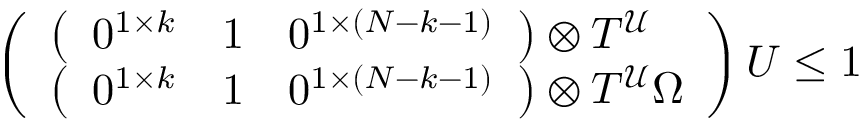Convert formula to latex. <formula><loc_0><loc_0><loc_500><loc_500>\begin{array} { r l } & { \left ( \begin{array} { l } { \left ( \begin{array} { l l l } { 0 ^ { 1 \times k } } & { 1 } & { 0 ^ { 1 \times ( N - k - 1 ) } } \end{array} \right ) \otimes T ^ { \mathcal { U } } } \\ { \left ( \begin{array} { l l l } { 0 ^ { 1 \times k } } & { 1 } & { 0 ^ { 1 \times ( N - k - 1 ) } } \end{array} \right ) \otimes T ^ { \mathcal { U } } \Omega } \end{array} \right ) U \leq 1 } \end{array}</formula> 